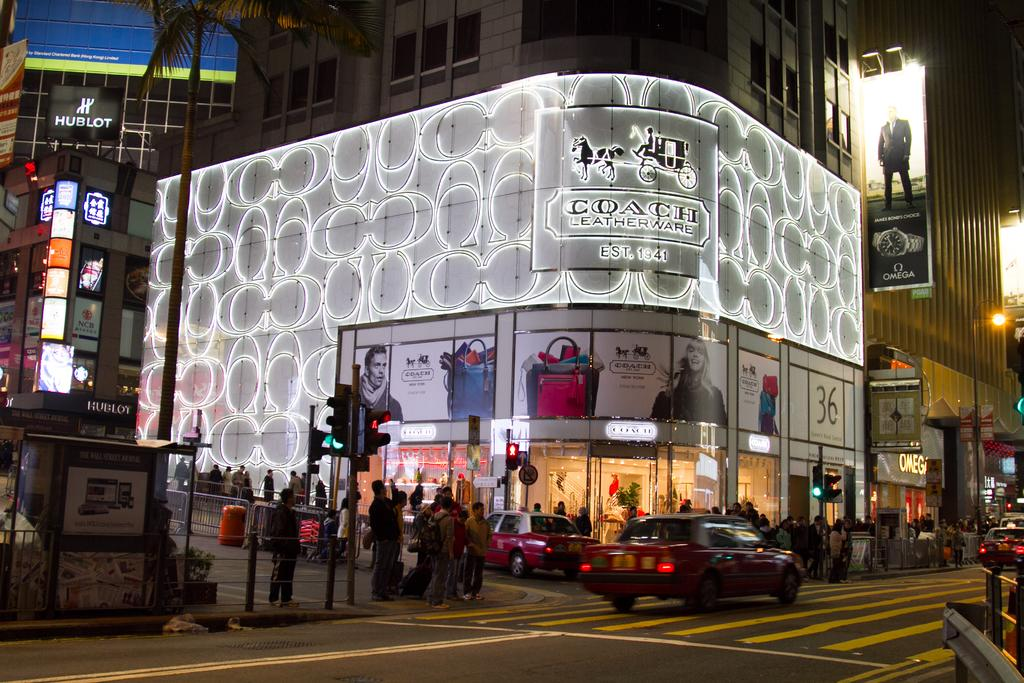Provide a one-sentence caption for the provided image. The sidewalk is full of pedestrians in front of the Coach Leatherware building at night. 